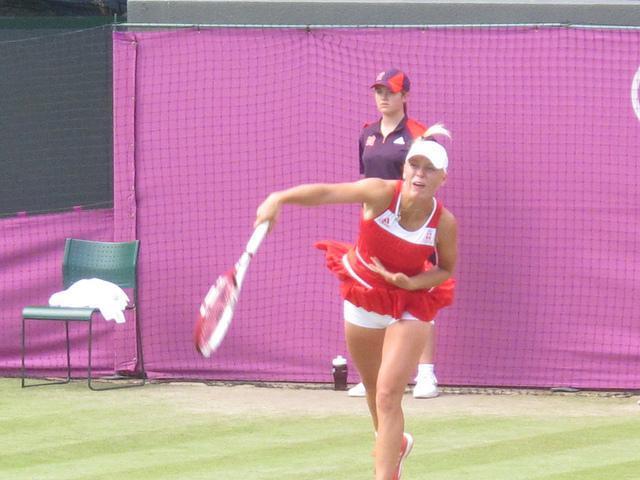How many people can you see?
Give a very brief answer. 2. How many tennis rackets are in the picture?
Give a very brief answer. 1. 